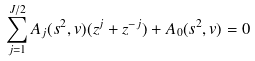Convert formula to latex. <formula><loc_0><loc_0><loc_500><loc_500>\sum _ { j = 1 } ^ { J / 2 } A _ { j } ( s ^ { 2 } , v ) ( z ^ { j } + z ^ { - j } ) + A _ { 0 } ( s ^ { 2 } , v ) = 0</formula> 